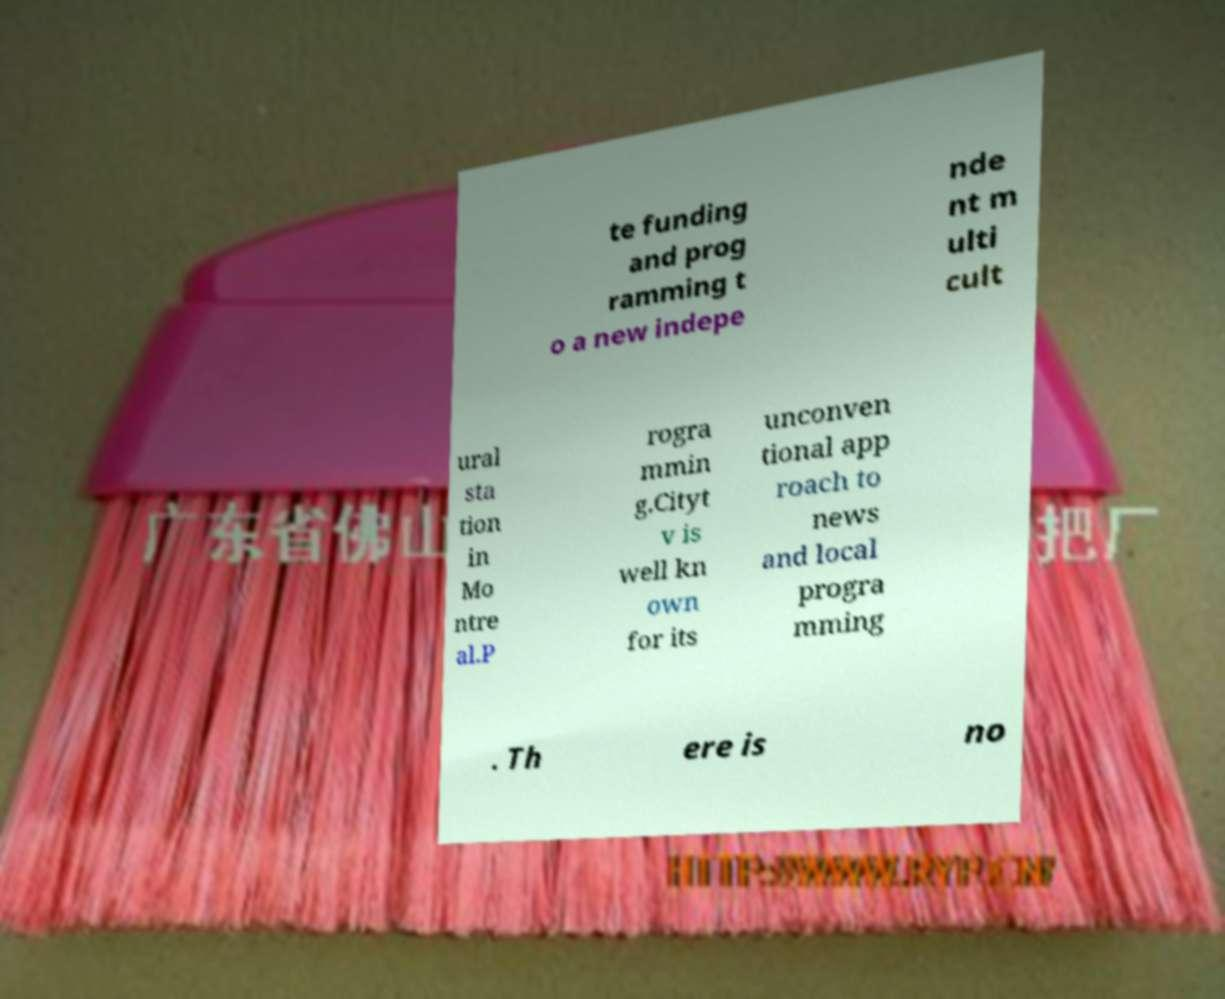I need the written content from this picture converted into text. Can you do that? te funding and prog ramming t o a new indepe nde nt m ulti cult ural sta tion in Mo ntre al.P rogra mmin g.Cityt v is well kn own for its unconven tional app roach to news and local progra mming . Th ere is no 